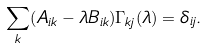<formula> <loc_0><loc_0><loc_500><loc_500>\sum _ { k } ( A _ { i k } - \lambda B _ { i k } ) \Gamma _ { k j } ( \lambda ) = \delta _ { i j } .</formula> 